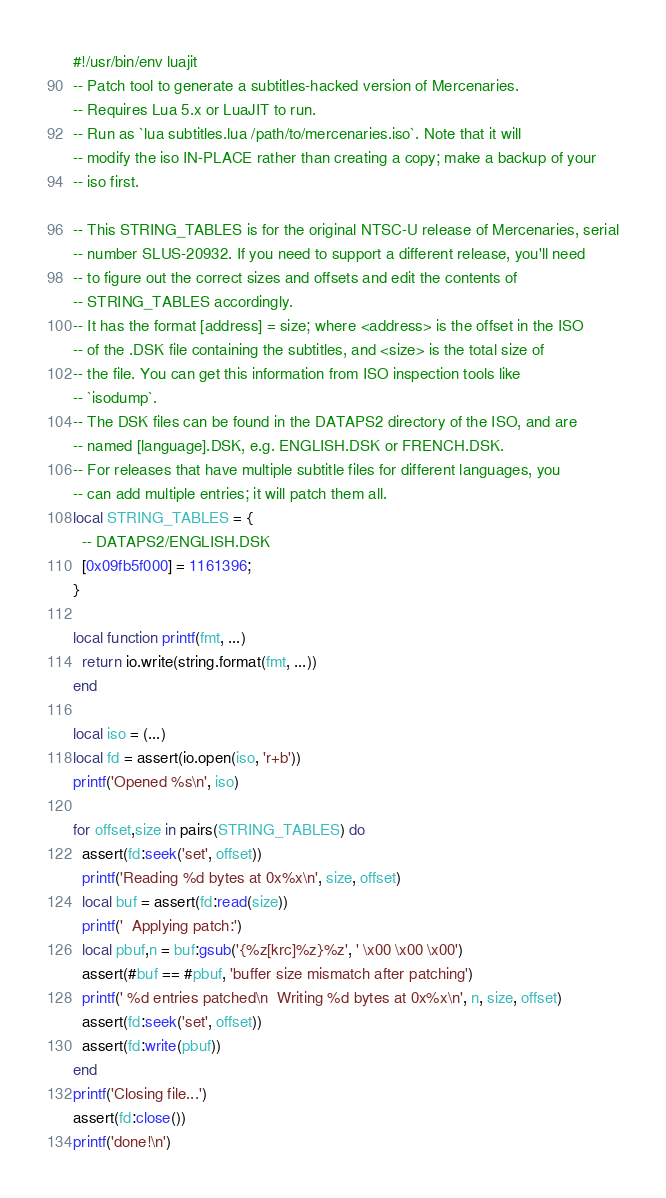Convert code to text. <code><loc_0><loc_0><loc_500><loc_500><_Lua_>#!/usr/bin/env luajit
-- Patch tool to generate a subtitles-hacked version of Mercenaries.
-- Requires Lua 5.x or LuaJIT to run.
-- Run as `lua subtitles.lua /path/to/mercenaries.iso`. Note that it will
-- modify the iso IN-PLACE rather than creating a copy; make a backup of your
-- iso first.

-- This STRING_TABLES is for the original NTSC-U release of Mercenaries, serial
-- number SLUS-20932. If you need to support a different release, you'll need
-- to figure out the correct sizes and offsets and edit the contents of
-- STRING_TABLES accordingly.
-- It has the format [address] = size; where <address> is the offset in the ISO
-- of the .DSK file containing the subtitles, and <size> is the total size of
-- the file. You can get this information from ISO inspection tools like
-- `isodump`.
-- The DSK files can be found in the DATAPS2 directory of the ISO, and are
-- named [language].DSK, e.g. ENGLISH.DSK or FRENCH.DSK.
-- For releases that have multiple subtitle files for different languages, you
-- can add multiple entries; it will patch them all.
local STRING_TABLES = {
  -- DATAPS2/ENGLISH.DSK
  [0x09fb5f000] = 1161396;
}

local function printf(fmt, ...)
  return io.write(string.format(fmt, ...))
end

local iso = (...)
local fd = assert(io.open(iso, 'r+b'))
printf('Opened %s\n', iso)

for offset,size in pairs(STRING_TABLES) do
  assert(fd:seek('set', offset))
  printf('Reading %d bytes at 0x%x\n', size, offset)
  local buf = assert(fd:read(size))
  printf('  Applying patch:')
  local pbuf,n = buf:gsub('{%z[krc]%z}%z', ' \x00 \x00 \x00')
  assert(#buf == #pbuf, 'buffer size mismatch after patching')
  printf(' %d entries patched\n  Writing %d bytes at 0x%x\n', n, size, offset)
  assert(fd:seek('set', offset))
  assert(fd:write(pbuf))
end
printf('Closing file...')
assert(fd:close())
printf('done!\n')
</code> 